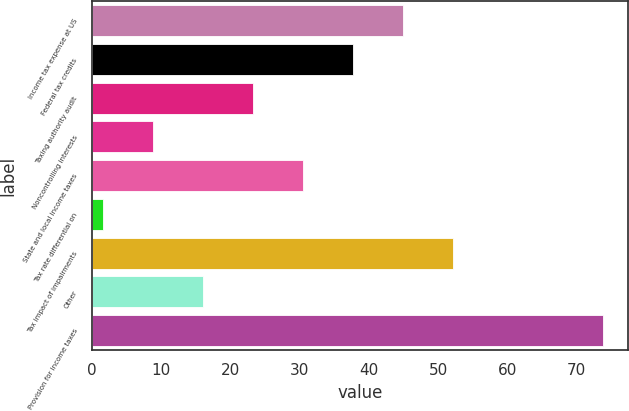Convert chart. <chart><loc_0><loc_0><loc_500><loc_500><bar_chart><fcel>Income tax expense at US<fcel>Federal tax credits<fcel>Taxing authority audit<fcel>Noncontrolling interests<fcel>State and local income taxes<fcel>Tax rate differential on<fcel>Tax impact of impairments<fcel>Other<fcel>Provision for income taxes<nl><fcel>44.89<fcel>37.68<fcel>23.26<fcel>8.84<fcel>30.47<fcel>1.63<fcel>52.1<fcel>16.05<fcel>73.75<nl></chart> 